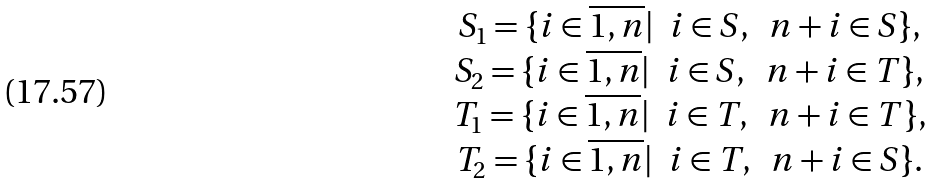<formula> <loc_0><loc_0><loc_500><loc_500>\begin{array} { c } S _ { 1 } = \{ i \in \overline { 1 , n } | \ \ i \in S , \ \ n + i \in S \} , \\ S _ { 2 } = \{ i \in \overline { 1 , n } | \ \ i \in S , \ \ n + i \in T \} , \\ T _ { 1 } = \{ i \in \overline { 1 , n } | \ \ i \in T , \ \ n + i \in T \} , \\ T _ { 2 } = \{ i \in \overline { 1 , n } | \ \ i \in T , \ \ n + i \in S \} . \end{array}</formula> 